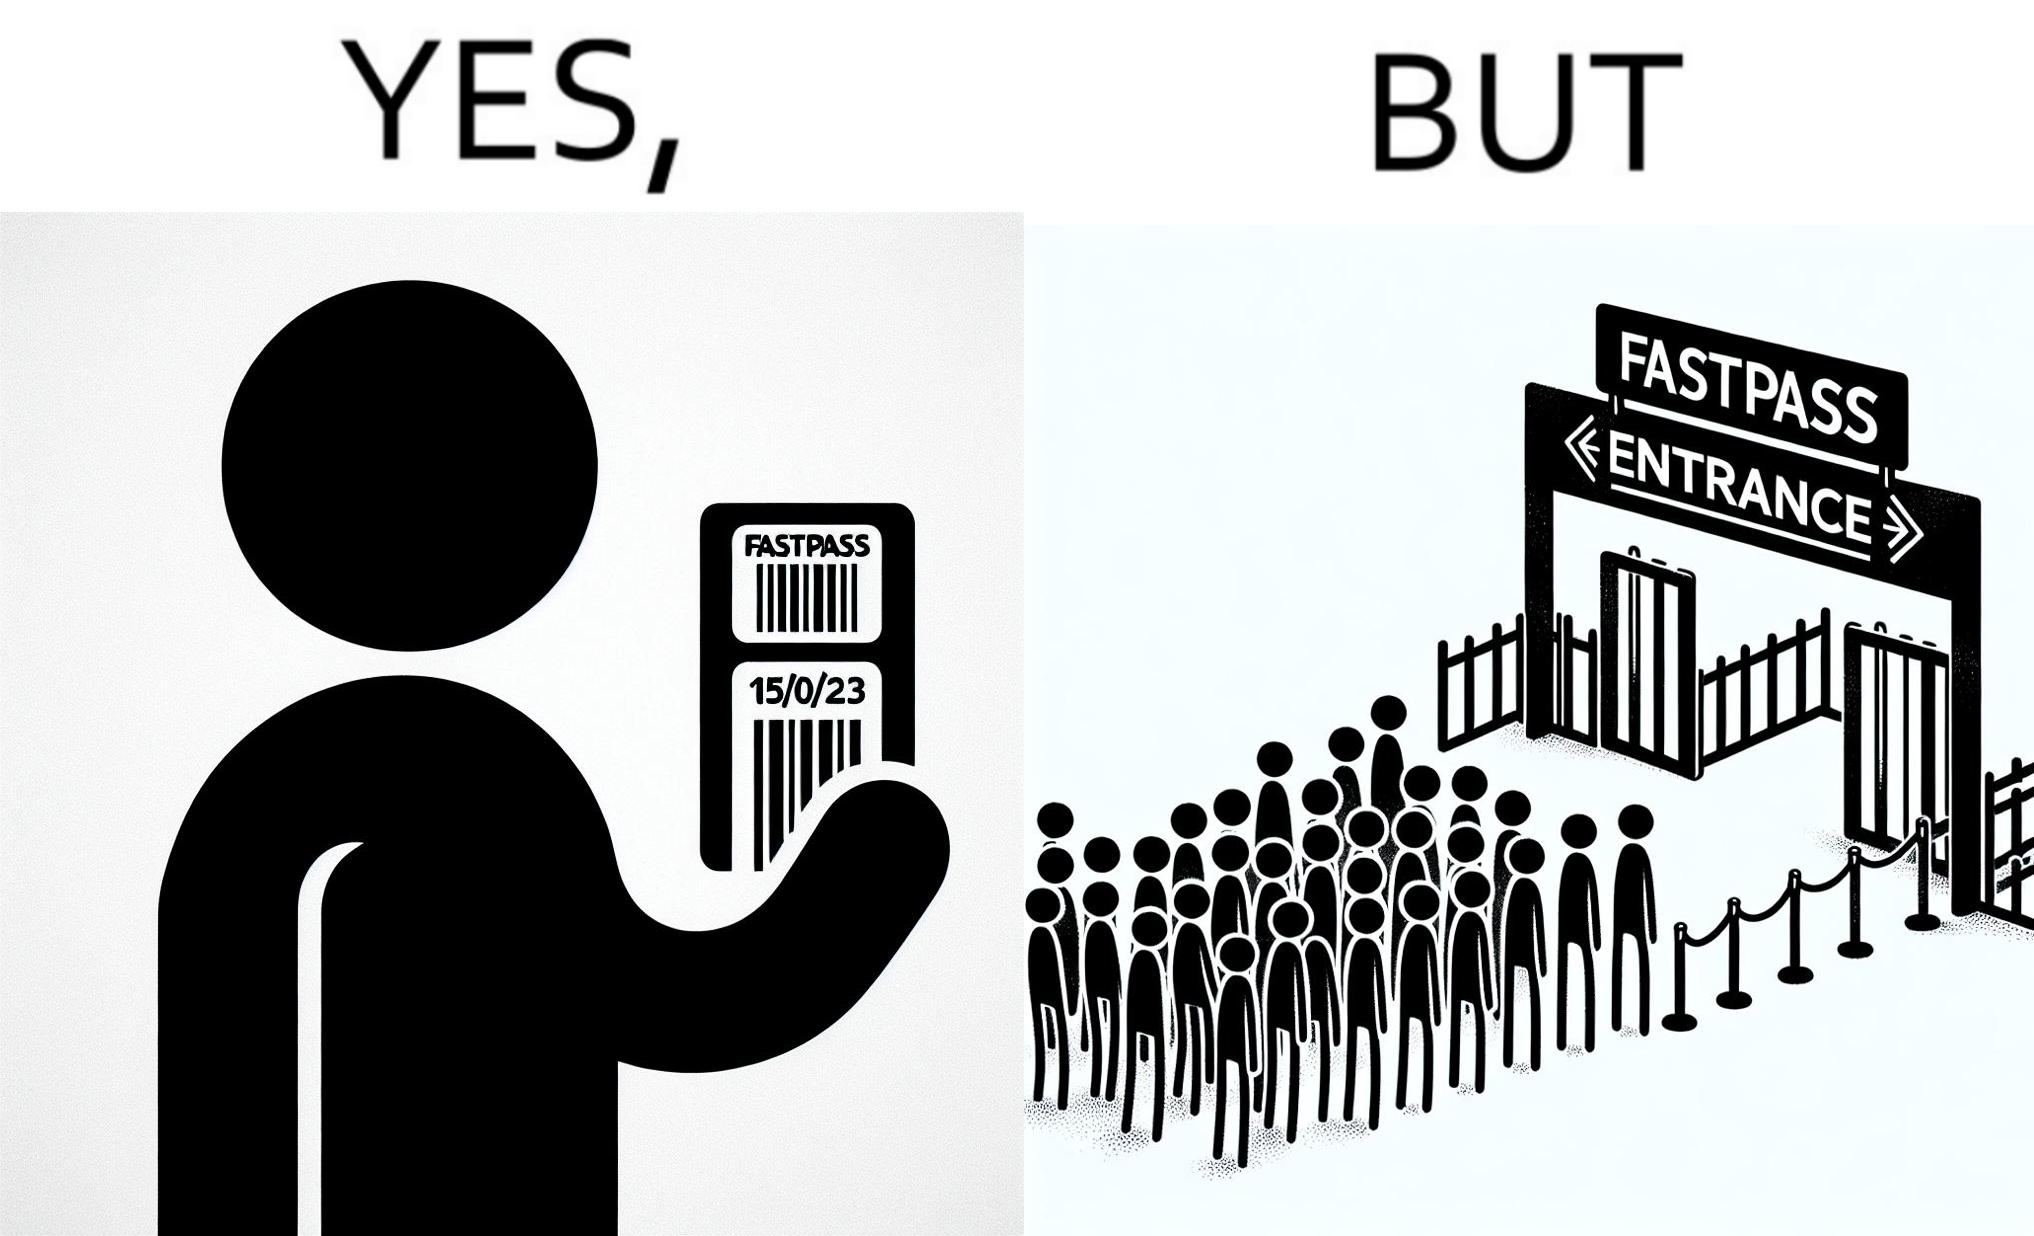Compare the left and right sides of this image. In the left part of the image: a person holding a "FASTPASS ENTRANCE" ticket or token of date "15/05/23" with some barcode In the right part of the image: people in a long queue in front of "FASTPASS ENTRANCE"  gate and "ENTRANCE" gate is vacant without any queue 